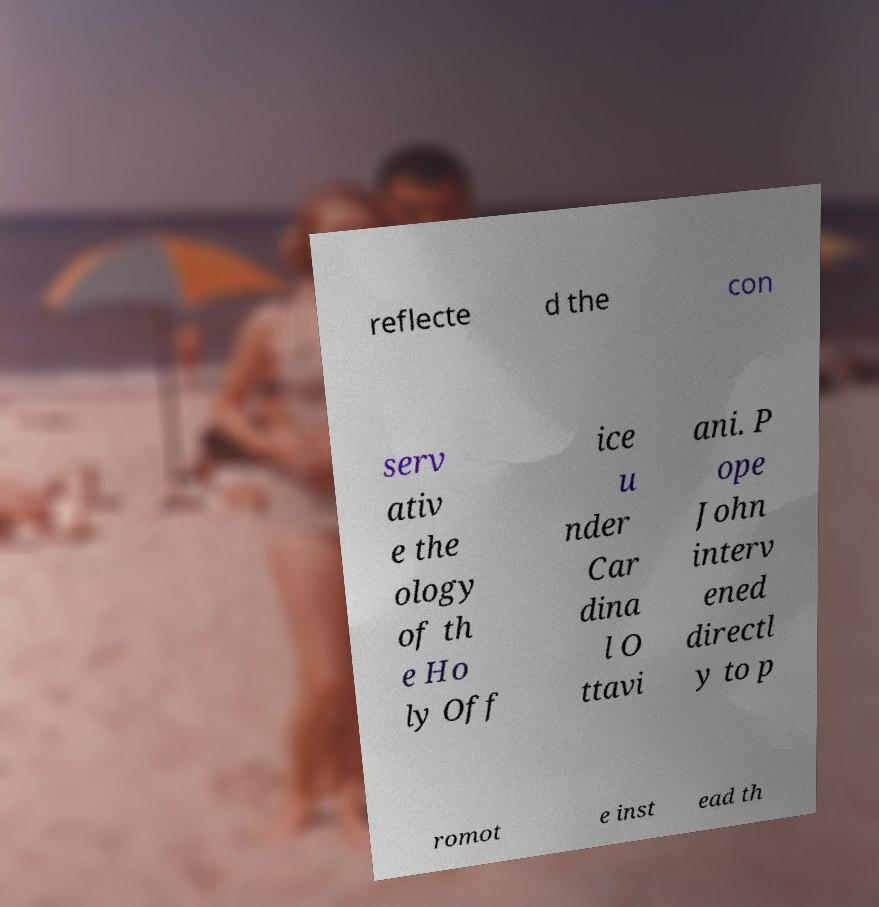Please identify and transcribe the text found in this image. reflecte d the con serv ativ e the ology of th e Ho ly Off ice u nder Car dina l O ttavi ani. P ope John interv ened directl y to p romot e inst ead th 